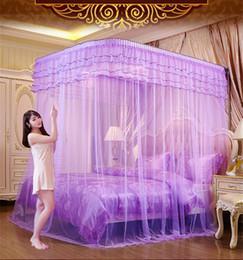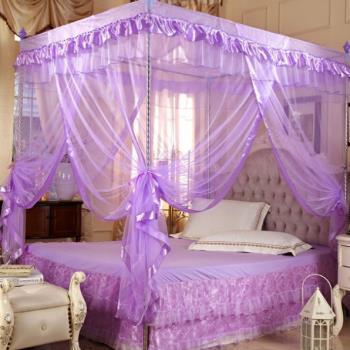The first image is the image on the left, the second image is the image on the right. Considering the images on both sides, is "One of the images includes a human." valid? Answer yes or no. Yes. The first image is the image on the left, the second image is the image on the right. Assess this claim about the two images: "A brunette woman in a negligee is posed with one of the purple canopy beds.". Correct or not? Answer yes or no. Yes. 